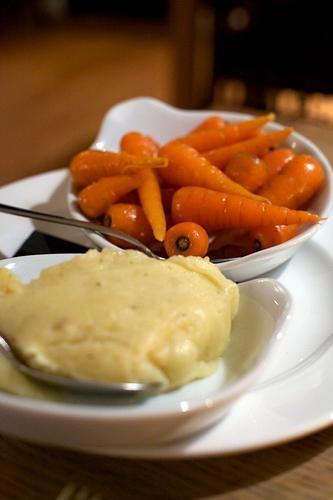How many bowls are on the plate?
Give a very brief answer. 2. How many types of food are on the plate?
Give a very brief answer. 2. How many utensils are on the plate?
Give a very brief answer. 2. How many utensils can be seen in the photo?
Give a very brief answer. 2. How many plates are in the photo?
Give a very brief answer. 1. 